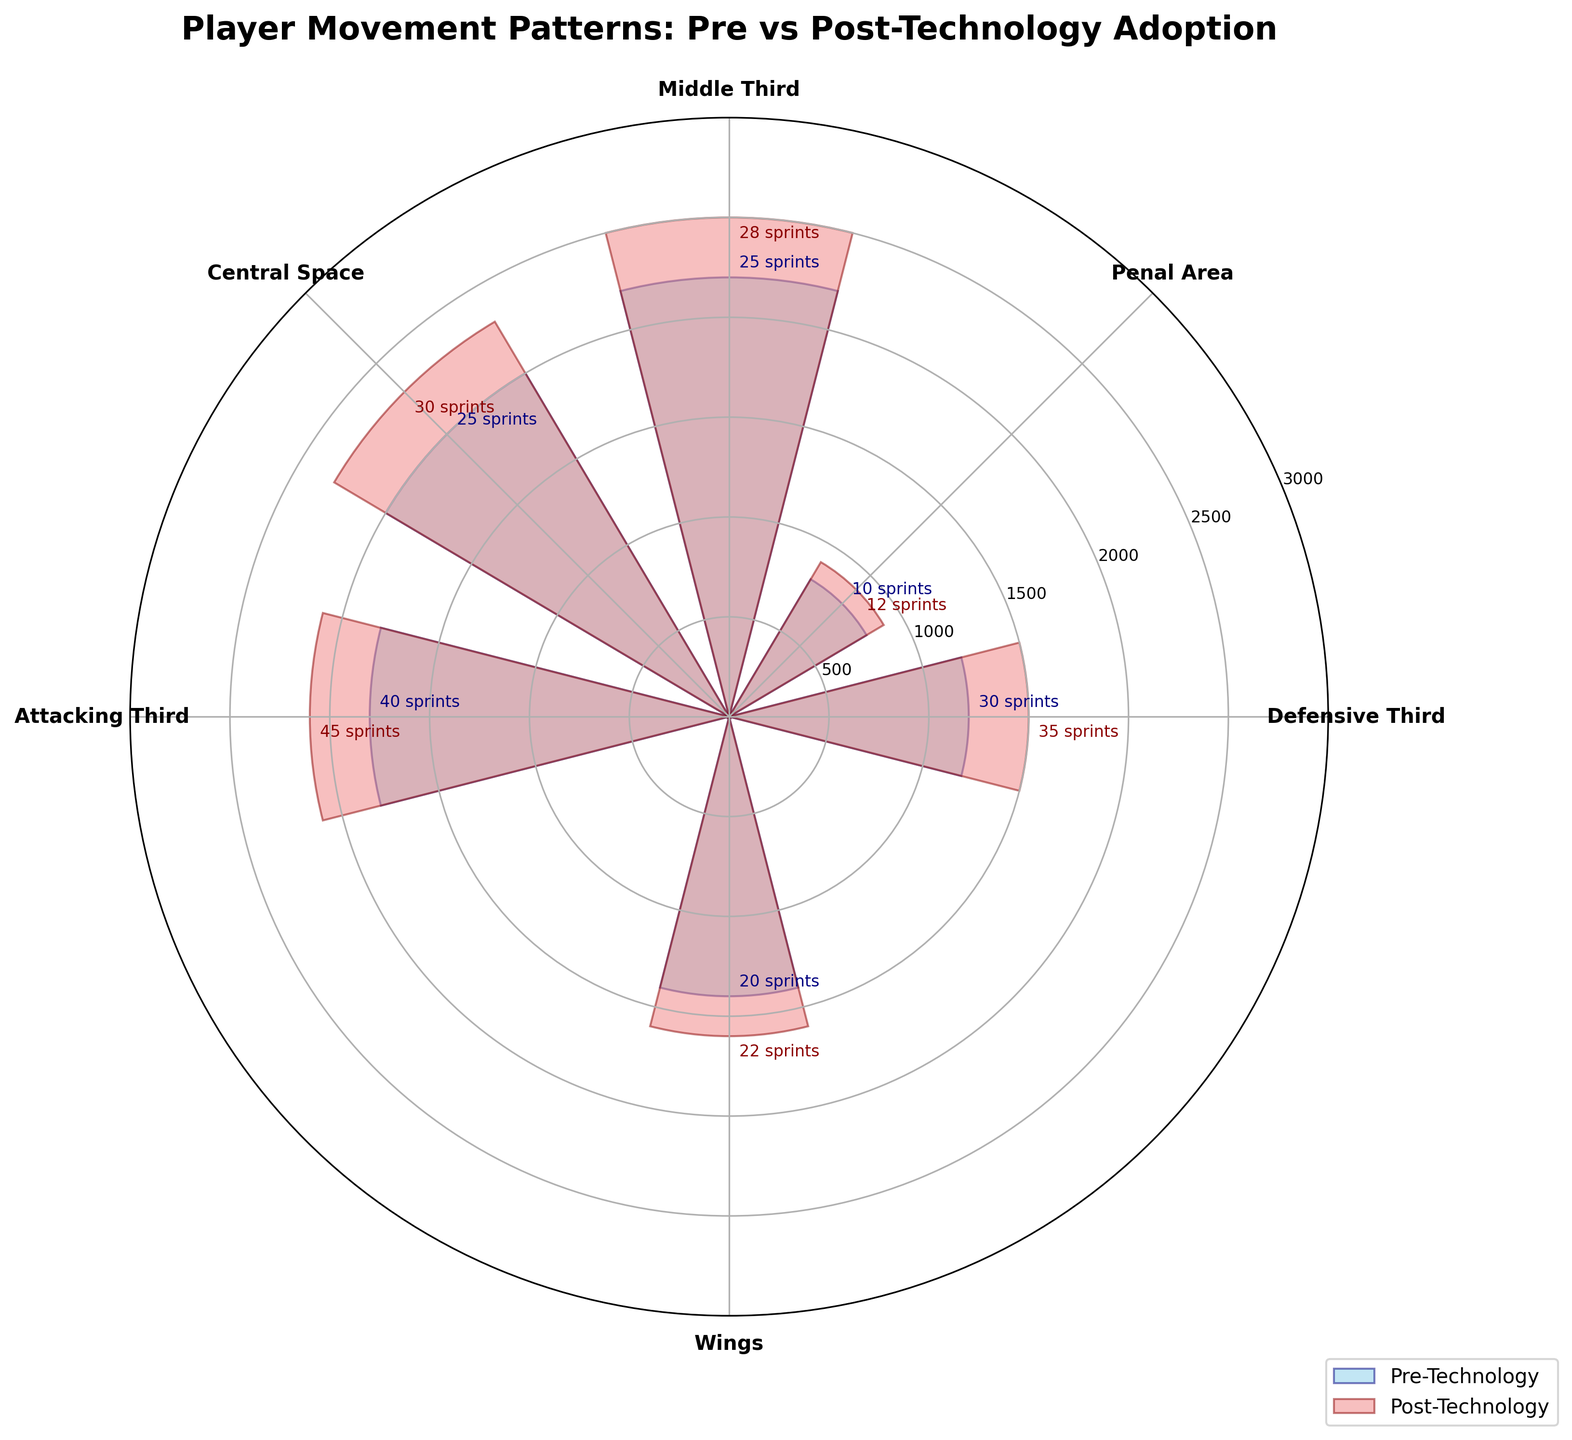What is the title of the figure? The title is usually located at the top of the figure. It provides an overview of the main topic that the chart covers. Here, it reads "Player Movement Patterns: Pre vs Post-Technology Adoption".
Answer: Player Movement Patterns: Pre vs Post-Technology Adoption How many field zones are represented in the chart? You can count the number of distinct labels displayed around the edges of the chart. Each label represents a field zone. The labels are "Defensive Third," "Middle Third," "Attacking Third," "Wings," "Penal Area," and "Central Space".
Answer: Six Which field zone shows the greatest increase in distance covered after technology adoption? Compare the heights of the bars before and after technology adoption in each field zone. The difference is largest in the Middle Third zone, increasing from 2200 meters to 2500 meters.
Answer: Middle Third How many sprints were recorded in the Central Space post-technology adoption? Look at the annotations next to the Central Space post-technology bar. The annotation should specify the number of sprints. The figure indicates '30 sprints' for the Central Space post-technology bar.
Answer: 30 In which field zone is the average speed the highest during the pre-technology period? Hover over each field zone's pre-technology bar and check the "Average Speed (m/s)" annotations. The highest average speed during the pre-technology period is in the Middle Third with 6.2 m/s.
Answer: Middle Third What is the difference in the number of sprints recorded in the Attacking Third pre- and post-technology? Identify the number of sprints in the Attacking Third pre- and post-technology bars using the annotations. For the pre-technology period, it is 40 sprints, and for the post-technology period, it is 45 sprints. The difference is 45 - 40 = 5 sprints.
Answer: 5 Is there any field zone where the number of sprints remained the same pre- and post-technology adoption? Compare the annotations for the number of sprints in each field zone before and after technology adoption. The only field zone where the number of sprints remains unchanged is "Wings" with 20 sprints pre- and post-technology.
Answer: Wings Which color represents the post-technology data in the figure? The post-technology bars are shaded differently from the pre-technology bars. The legend on the right side of the figure indicates that the post-technology data is represented by light coral color.
Answer: Light Coral What field zone corresponds to the direction angle of 270 degrees? The labels on the horizontal axis (around the edges of the figure) indicate the field zones and their corresponding directions. The field zone at 270 degrees is "Wings".
Answer: Wings Which field zone has the smallest distance covered in the post-technology period? Look at which post-technology bar is the shortest. The shortest bar for post-technology distance covered is in the "Penal Area" with 900 meters.
Answer: Penal Area 